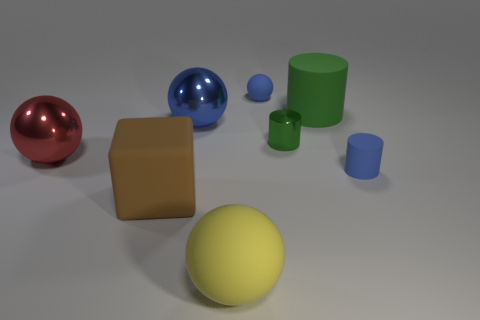Are there the same number of gray matte cylinders and rubber blocks?
Provide a short and direct response. No. Does the small matte object that is in front of the large blue shiny ball have the same shape as the big rubber object that is to the right of the blue matte sphere?
Give a very brief answer. Yes. Are there any cubes made of the same material as the yellow ball?
Your answer should be compact. Yes. What number of yellow objects are either rubber cubes or metal things?
Offer a terse response. 0. There is a thing that is both behind the brown matte object and in front of the big red metal object; what size is it?
Provide a short and direct response. Small. Are there more matte cylinders in front of the small sphere than brown rubber cubes?
Your response must be concise. Yes. What number of cubes are either green things or blue matte objects?
Provide a succinct answer. 0. The large object that is in front of the red metallic object and to the right of the brown rubber object has what shape?
Your response must be concise. Sphere. Are there the same number of green rubber objects that are left of the tiny green cylinder and green objects to the left of the cube?
Your answer should be compact. Yes. How many objects are either large green rubber cylinders or brown cubes?
Give a very brief answer. 2. 